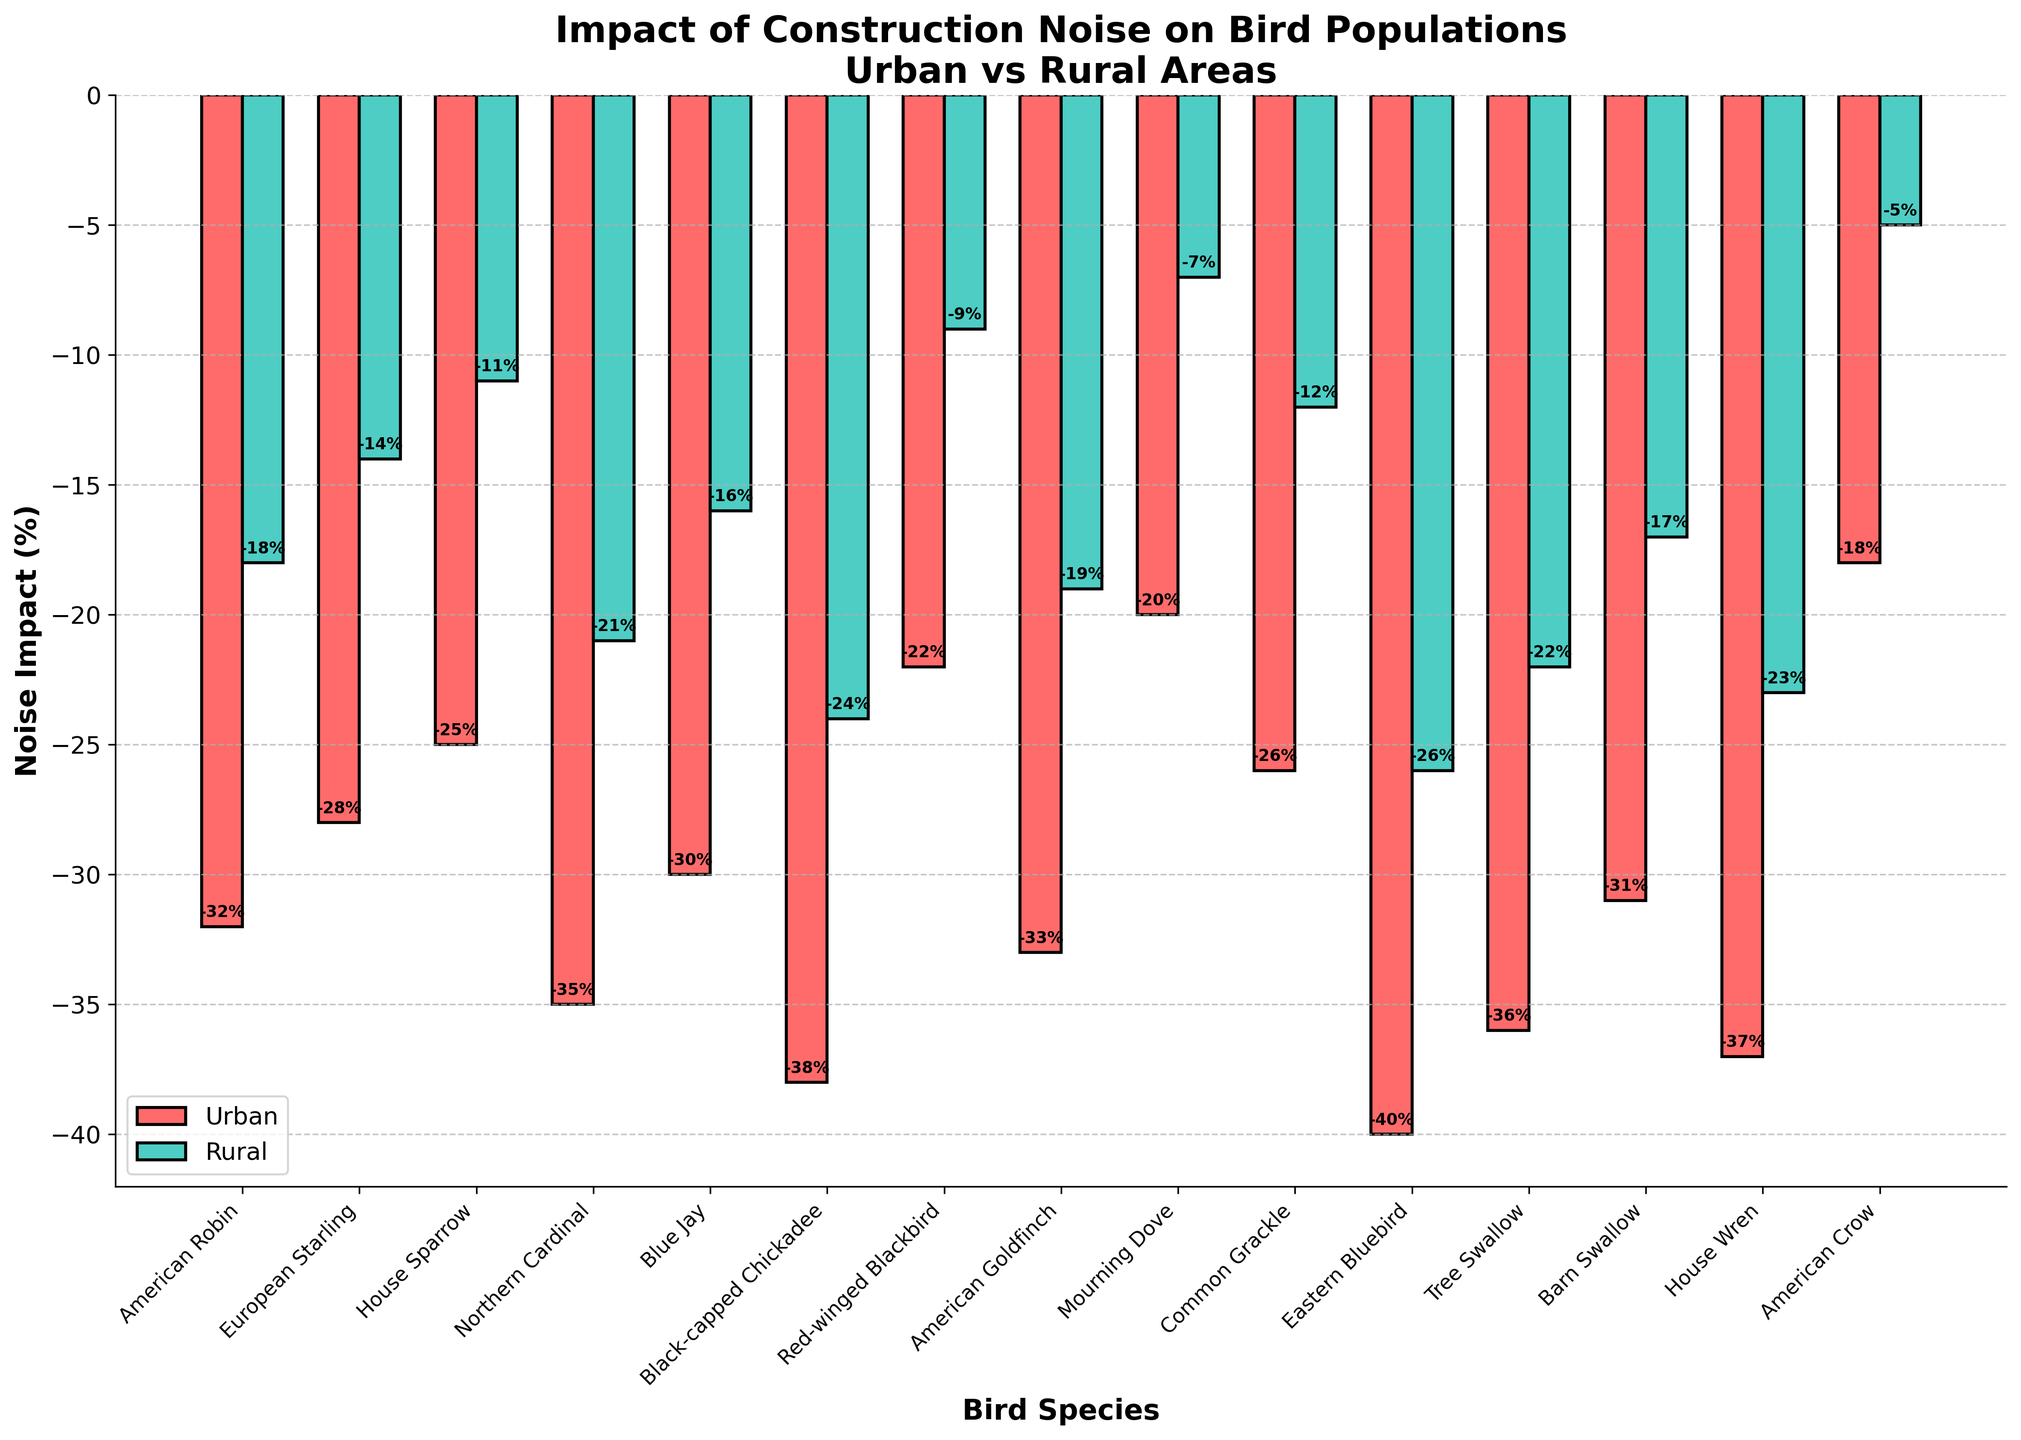Which bird species experiences the highest impact from urban noise? The bar for "Eastern Bluebird" is the tallest (most negative) in the "Urban" category, indicating the highest impact.
Answer: Eastern Bluebird Which bird species experiences the least impact from rural noise? The bar for "American Crow" is the shortest (least negative) in the "Rural" category, indicating the least impact.
Answer: American Crow What is the average impact of urban noise on the American Robin and House Sparrow? The impact on the American Robin is -32% and on the House Sparrow is -25%. The average is calculated as (-32 + -25) / 2 = -28.5%.
Answer: -28.5% How much greater is the impact of urban noise on the Black-capped Chickadee compared to the American Crow? The impact on the Black-capped Chickadee is -38% and on the American Crow is -18%. The difference is calculated as -38 - (-18) = -20%.
Answer: -20% Which bird species shows a greater difference in noise impact between urban and rural areas, the Blue Jay or the Tree Swallow? The difference for Blue Jay is -30 - (-16) = -14%, and for Tree Swallow it is -36 - (-22) = -14%. Both species show an equal difference in impact.
Answer: Equal Which area, urban or rural, generally shows a greater negative impact on bird populations? By observing the height of the bars, the urban bars consistently show a greater negative impact compared to the rural bars.
Answer: Urban What is the visual difference between the urban and rural impact bars for the Common Grackle? The "Urban" bar is significantly taller (more negative) than the "Rural" bar for the Common Grackle.
Answer: Urban bar is taller What is the median impact value for rural noise on all bird species? The sorted impacts for rural areas are: -26, -24, -23, -22, -21, -19, -18, -17, -16, -14, -12, -11, -9, -7, -5. The middle value in the sorted list (15 values) is -16.
Answer: -16 Which bird species shows the smallest difference in noise impact between urban and rural areas? The difference for each species needs to be calculated, but "American Crow" with -18% (urban) and -5% (rural), giving a difference of -18 - (-5) = -13%, which is the smallest.
Answer: American Crow On average, how much more impactful is urban noise compared to rural noise across all bird species? Calculate the average impact for both urban and rural across all species and compare. Urban impact values summarize to -471, and rural impact values to -220. Average impact: Urban = -471/15 = -31.4%, Rural = -220/15 = -14.67%. The difference is -31.4 - (-14.67) = -16.73%.
Answer: -16.73% 